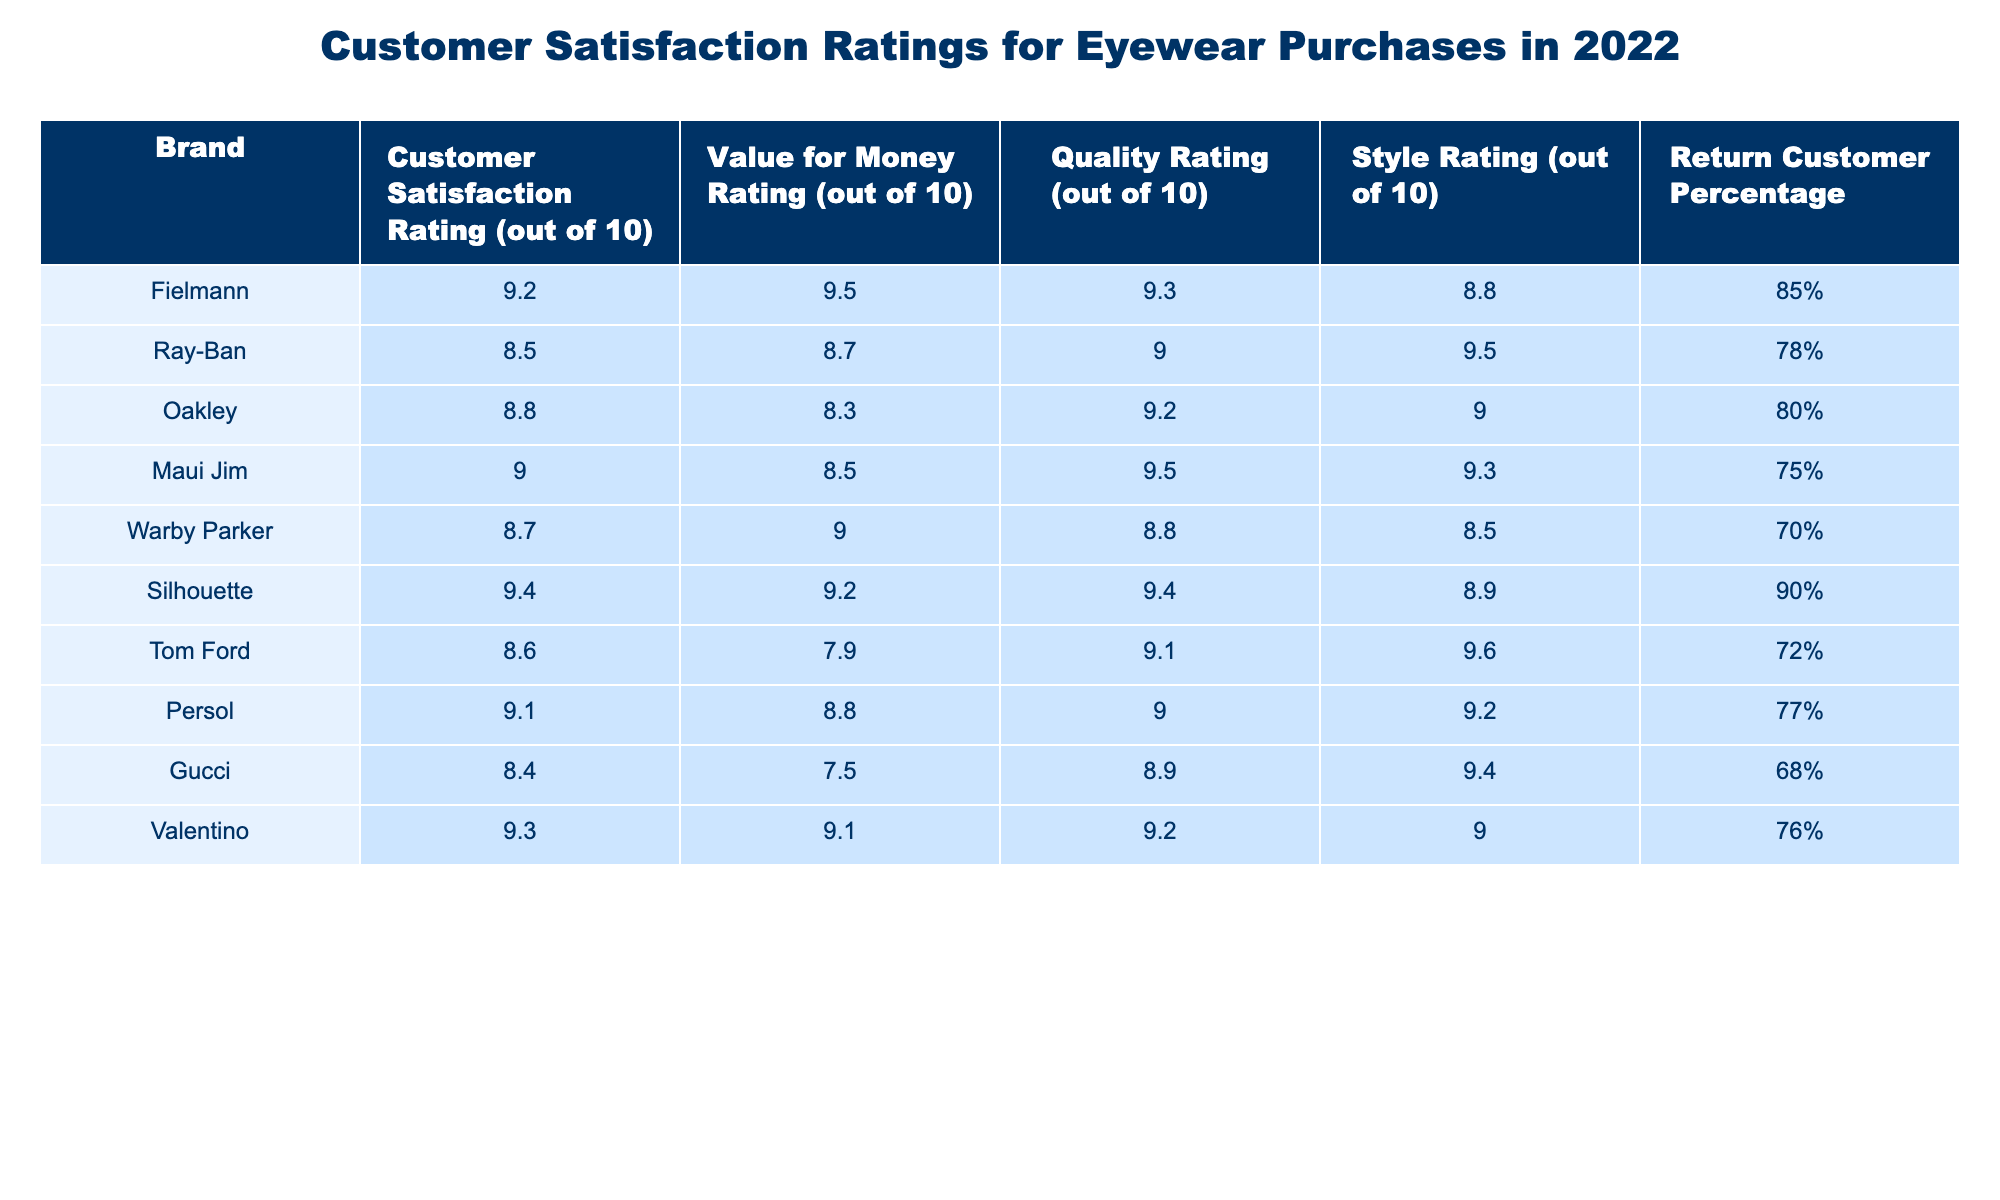What is Fielmann's Customer Satisfaction Rating? Looking at the table, the Customer Satisfaction Rating for Fielmann is clearly noted as 9.2 out of 10.
Answer: 9.2 Which brand has the highest Quality Rating? The Quality Ratings in the table reveal that Silhouette has the highest Quality Rating of 9.4 out of 10.
Answer: Silhouette How does Fielmann's Value for Money Rating compare to Gucci's? By comparing the Value for Money Ratings, Fielmann has a rating of 9.5, while Gucci has 7.5, indicating that Fielmann provides significantly better value for money.
Answer: Fielmann is higher What is the return customer percentage for Maui Jim? From the table, Maui Jim has a Return Customer Percentage of 75%.
Answer: 75% Which brand has the lowest Style Rating, and what is that rating? According to the Style Ratings listed, Warby Parker has the lowest Style Rating at 8.5 out of 10.
Answer: Warby Parker, 8.5 What is the difference in Customer Satisfaction Ratings between Fielmann and Ray-Ban? Fielmann's rating is 9.2 and Ray-Ban's is 8.5. The difference is 9.2 - 8.5 = 0.7.
Answer: 0.7 Is the Return Customer Percentage for Silhouette greater than 80%? The Return Customer Percentage for Silhouette is 90%, which is greater than 80%.
Answer: Yes Calculate the average Value for Money Rating for the brands listed. The Value for Money Ratings are 9.5, 8.7, 8.3, 8.5, 9.0, 9.2, 7.9, 8.8, 7.5 and 9.1. The sum is 87.5, and there are 10 brands, so the average is 87.5 / 10 = 8.75.
Answer: 8.75 What percentage of return customers does Persol have in comparison to Warby Parker? Persol has a Return Customer Percentage of 77%, while Warby Parker has 70%. Persol has a higher percentage by 7%.
Answer: Persol is higher by 7% Which brand has the highest Customer Satisfaction Rating among the top three brands? The top three brands based on Customer Satisfaction Ratings are Fielmann (9.2), Silhouette (9.4), and Maui Jim (9.0). Silhouette has the highest among them at 9.4.
Answer: Silhouette 